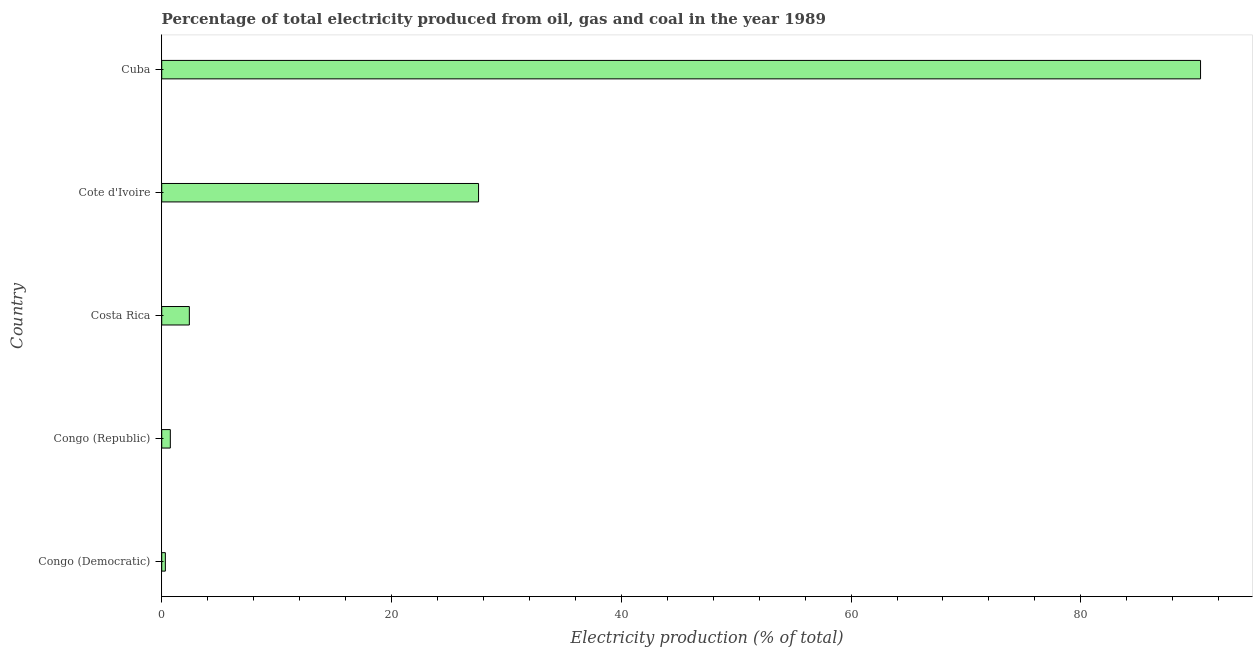Does the graph contain any zero values?
Offer a terse response. No. Does the graph contain grids?
Offer a very short reply. No. What is the title of the graph?
Your answer should be very brief. Percentage of total electricity produced from oil, gas and coal in the year 1989. What is the label or title of the X-axis?
Offer a terse response. Electricity production (% of total). What is the electricity production in Congo (Democratic)?
Provide a short and direct response. 0.32. Across all countries, what is the maximum electricity production?
Your response must be concise. 90.42. Across all countries, what is the minimum electricity production?
Your answer should be very brief. 0.32. In which country was the electricity production maximum?
Provide a succinct answer. Cuba. In which country was the electricity production minimum?
Offer a terse response. Congo (Democratic). What is the sum of the electricity production?
Keep it short and to the point. 121.47. What is the difference between the electricity production in Costa Rica and Cuba?
Make the answer very short. -88.02. What is the average electricity production per country?
Keep it short and to the point. 24.29. What is the median electricity production?
Offer a very short reply. 2.4. In how many countries, is the electricity production greater than 16 %?
Keep it short and to the point. 2. What is the ratio of the electricity production in Congo (Democratic) to that in Cote d'Ivoire?
Give a very brief answer. 0.01. Is the electricity production in Costa Rica less than that in Cote d'Ivoire?
Your response must be concise. Yes. Is the difference between the electricity production in Congo (Republic) and Cuba greater than the difference between any two countries?
Offer a terse response. No. What is the difference between the highest and the second highest electricity production?
Make the answer very short. 62.84. What is the difference between the highest and the lowest electricity production?
Offer a very short reply. 90.1. In how many countries, is the electricity production greater than the average electricity production taken over all countries?
Keep it short and to the point. 2. Are all the bars in the graph horizontal?
Make the answer very short. Yes. Are the values on the major ticks of X-axis written in scientific E-notation?
Your answer should be compact. No. What is the Electricity production (% of total) of Congo (Democratic)?
Make the answer very short. 0.32. What is the Electricity production (% of total) of Costa Rica?
Your answer should be very brief. 2.4. What is the Electricity production (% of total) of Cote d'Ivoire?
Make the answer very short. 27.58. What is the Electricity production (% of total) of Cuba?
Keep it short and to the point. 90.42. What is the difference between the Electricity production (% of total) in Congo (Democratic) and Congo (Republic)?
Give a very brief answer. -0.43. What is the difference between the Electricity production (% of total) in Congo (Democratic) and Costa Rica?
Provide a succinct answer. -2.09. What is the difference between the Electricity production (% of total) in Congo (Democratic) and Cote d'Ivoire?
Your response must be concise. -27.26. What is the difference between the Electricity production (% of total) in Congo (Democratic) and Cuba?
Provide a short and direct response. -90.1. What is the difference between the Electricity production (% of total) in Congo (Republic) and Costa Rica?
Keep it short and to the point. -1.65. What is the difference between the Electricity production (% of total) in Congo (Republic) and Cote d'Ivoire?
Your response must be concise. -26.83. What is the difference between the Electricity production (% of total) in Congo (Republic) and Cuba?
Your answer should be compact. -89.67. What is the difference between the Electricity production (% of total) in Costa Rica and Cote d'Ivoire?
Keep it short and to the point. -25.17. What is the difference between the Electricity production (% of total) in Costa Rica and Cuba?
Provide a short and direct response. -88.01. What is the difference between the Electricity production (% of total) in Cote d'Ivoire and Cuba?
Ensure brevity in your answer.  -62.84. What is the ratio of the Electricity production (% of total) in Congo (Democratic) to that in Congo (Republic)?
Give a very brief answer. 0.42. What is the ratio of the Electricity production (% of total) in Congo (Democratic) to that in Costa Rica?
Offer a very short reply. 0.13. What is the ratio of the Electricity production (% of total) in Congo (Democratic) to that in Cote d'Ivoire?
Offer a very short reply. 0.01. What is the ratio of the Electricity production (% of total) in Congo (Democratic) to that in Cuba?
Provide a short and direct response. 0. What is the ratio of the Electricity production (% of total) in Congo (Republic) to that in Costa Rica?
Your answer should be compact. 0.31. What is the ratio of the Electricity production (% of total) in Congo (Republic) to that in Cote d'Ivoire?
Make the answer very short. 0.03. What is the ratio of the Electricity production (% of total) in Congo (Republic) to that in Cuba?
Make the answer very short. 0.01. What is the ratio of the Electricity production (% of total) in Costa Rica to that in Cote d'Ivoire?
Your answer should be very brief. 0.09. What is the ratio of the Electricity production (% of total) in Costa Rica to that in Cuba?
Offer a very short reply. 0.03. What is the ratio of the Electricity production (% of total) in Cote d'Ivoire to that in Cuba?
Your answer should be compact. 0.3. 